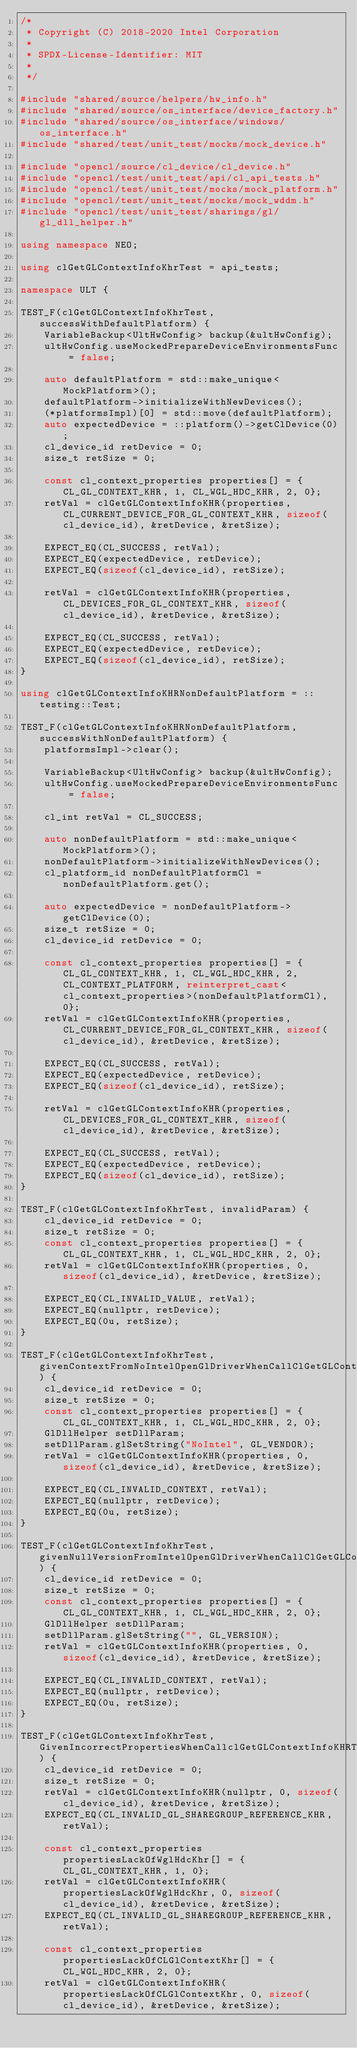<code> <loc_0><loc_0><loc_500><loc_500><_C++_>/*
 * Copyright (C) 2018-2020 Intel Corporation
 *
 * SPDX-License-Identifier: MIT
 *
 */

#include "shared/source/helpers/hw_info.h"
#include "shared/source/os_interface/device_factory.h"
#include "shared/source/os_interface/windows/os_interface.h"
#include "shared/test/unit_test/mocks/mock_device.h"

#include "opencl/source/cl_device/cl_device.h"
#include "opencl/test/unit_test/api/cl_api_tests.h"
#include "opencl/test/unit_test/mocks/mock_platform.h"
#include "opencl/test/unit_test/mocks/mock_wddm.h"
#include "opencl/test/unit_test/sharings/gl/gl_dll_helper.h"

using namespace NEO;

using clGetGLContextInfoKhrTest = api_tests;

namespace ULT {

TEST_F(clGetGLContextInfoKhrTest, successWithDefaultPlatform) {
    VariableBackup<UltHwConfig> backup(&ultHwConfig);
    ultHwConfig.useMockedPrepareDeviceEnvironmentsFunc = false;

    auto defaultPlatform = std::make_unique<MockPlatform>();
    defaultPlatform->initializeWithNewDevices();
    (*platformsImpl)[0] = std::move(defaultPlatform);
    auto expectedDevice = ::platform()->getClDevice(0);
    cl_device_id retDevice = 0;
    size_t retSize = 0;

    const cl_context_properties properties[] = {CL_GL_CONTEXT_KHR, 1, CL_WGL_HDC_KHR, 2, 0};
    retVal = clGetGLContextInfoKHR(properties, CL_CURRENT_DEVICE_FOR_GL_CONTEXT_KHR, sizeof(cl_device_id), &retDevice, &retSize);

    EXPECT_EQ(CL_SUCCESS, retVal);
    EXPECT_EQ(expectedDevice, retDevice);
    EXPECT_EQ(sizeof(cl_device_id), retSize);

    retVal = clGetGLContextInfoKHR(properties, CL_DEVICES_FOR_GL_CONTEXT_KHR, sizeof(cl_device_id), &retDevice, &retSize);

    EXPECT_EQ(CL_SUCCESS, retVal);
    EXPECT_EQ(expectedDevice, retDevice);
    EXPECT_EQ(sizeof(cl_device_id), retSize);
}

using clGetGLContextInfoKHRNonDefaultPlatform = ::testing::Test;

TEST_F(clGetGLContextInfoKHRNonDefaultPlatform, successWithNonDefaultPlatform) {
    platformsImpl->clear();

    VariableBackup<UltHwConfig> backup(&ultHwConfig);
    ultHwConfig.useMockedPrepareDeviceEnvironmentsFunc = false;

    cl_int retVal = CL_SUCCESS;

    auto nonDefaultPlatform = std::make_unique<MockPlatform>();
    nonDefaultPlatform->initializeWithNewDevices();
    cl_platform_id nonDefaultPlatformCl = nonDefaultPlatform.get();

    auto expectedDevice = nonDefaultPlatform->getClDevice(0);
    size_t retSize = 0;
    cl_device_id retDevice = 0;

    const cl_context_properties properties[] = {CL_GL_CONTEXT_KHR, 1, CL_WGL_HDC_KHR, 2, CL_CONTEXT_PLATFORM, reinterpret_cast<cl_context_properties>(nonDefaultPlatformCl), 0};
    retVal = clGetGLContextInfoKHR(properties, CL_CURRENT_DEVICE_FOR_GL_CONTEXT_KHR, sizeof(cl_device_id), &retDevice, &retSize);

    EXPECT_EQ(CL_SUCCESS, retVal);
    EXPECT_EQ(expectedDevice, retDevice);
    EXPECT_EQ(sizeof(cl_device_id), retSize);

    retVal = clGetGLContextInfoKHR(properties, CL_DEVICES_FOR_GL_CONTEXT_KHR, sizeof(cl_device_id), &retDevice, &retSize);

    EXPECT_EQ(CL_SUCCESS, retVal);
    EXPECT_EQ(expectedDevice, retDevice);
    EXPECT_EQ(sizeof(cl_device_id), retSize);
}

TEST_F(clGetGLContextInfoKhrTest, invalidParam) {
    cl_device_id retDevice = 0;
    size_t retSize = 0;
    const cl_context_properties properties[] = {CL_GL_CONTEXT_KHR, 1, CL_WGL_HDC_KHR, 2, 0};
    retVal = clGetGLContextInfoKHR(properties, 0, sizeof(cl_device_id), &retDevice, &retSize);

    EXPECT_EQ(CL_INVALID_VALUE, retVal);
    EXPECT_EQ(nullptr, retDevice);
    EXPECT_EQ(0u, retSize);
}

TEST_F(clGetGLContextInfoKhrTest, givenContextFromNoIntelOpenGlDriverWhenCallClGetGLContextInfoKHRThenReturnClInvalidContext) {
    cl_device_id retDevice = 0;
    size_t retSize = 0;
    const cl_context_properties properties[] = {CL_GL_CONTEXT_KHR, 1, CL_WGL_HDC_KHR, 2, 0};
    GlDllHelper setDllParam;
    setDllParam.glSetString("NoIntel", GL_VENDOR);
    retVal = clGetGLContextInfoKHR(properties, 0, sizeof(cl_device_id), &retDevice, &retSize);

    EXPECT_EQ(CL_INVALID_CONTEXT, retVal);
    EXPECT_EQ(nullptr, retDevice);
    EXPECT_EQ(0u, retSize);
}

TEST_F(clGetGLContextInfoKhrTest, givenNullVersionFromIntelOpenGlDriverWhenCallClGetGLContextInfoKHRThenReturnClInvalidContext) {
    cl_device_id retDevice = 0;
    size_t retSize = 0;
    const cl_context_properties properties[] = {CL_GL_CONTEXT_KHR, 1, CL_WGL_HDC_KHR, 2, 0};
    GlDllHelper setDllParam;
    setDllParam.glSetString("", GL_VERSION);
    retVal = clGetGLContextInfoKHR(properties, 0, sizeof(cl_device_id), &retDevice, &retSize);

    EXPECT_EQ(CL_INVALID_CONTEXT, retVal);
    EXPECT_EQ(nullptr, retDevice);
    EXPECT_EQ(0u, retSize);
}

TEST_F(clGetGLContextInfoKhrTest, GivenIncorrectPropertiesWhenCallclGetGLContextInfoKHRThenReturnClInvalidGlShareGroupRererencKhr) {
    cl_device_id retDevice = 0;
    size_t retSize = 0;
    retVal = clGetGLContextInfoKHR(nullptr, 0, sizeof(cl_device_id), &retDevice, &retSize);
    EXPECT_EQ(CL_INVALID_GL_SHAREGROUP_REFERENCE_KHR, retVal);

    const cl_context_properties propertiesLackOfWglHdcKhr[] = {CL_GL_CONTEXT_KHR, 1, 0};
    retVal = clGetGLContextInfoKHR(propertiesLackOfWglHdcKhr, 0, sizeof(cl_device_id), &retDevice, &retSize);
    EXPECT_EQ(CL_INVALID_GL_SHAREGROUP_REFERENCE_KHR, retVal);

    const cl_context_properties propertiesLackOfCLGlContextKhr[] = {CL_WGL_HDC_KHR, 2, 0};
    retVal = clGetGLContextInfoKHR(propertiesLackOfCLGlContextKhr, 0, sizeof(cl_device_id), &retDevice, &retSize);</code> 